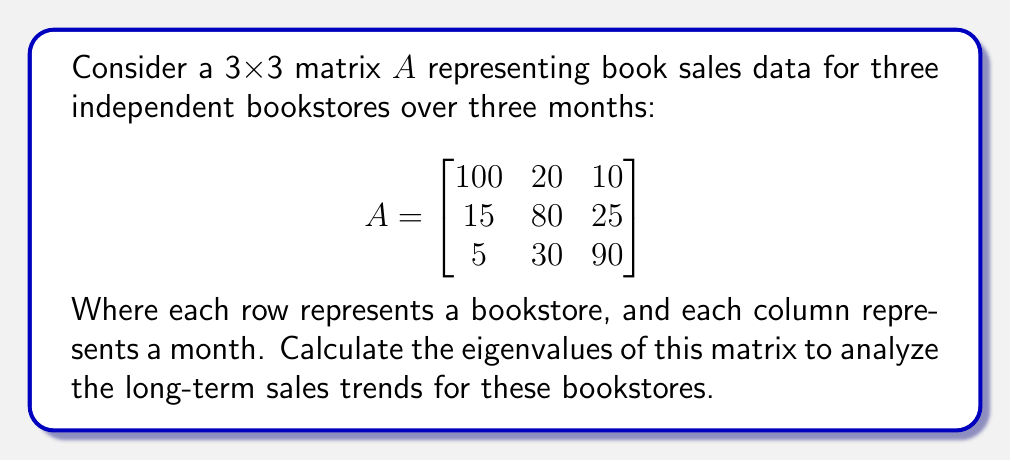Can you answer this question? To find the eigenvalues of matrix A, we need to solve the characteristic equation:

1) First, we calculate det(A - λI), where I is the 3x3 identity matrix:

   $$det\begin{pmatrix}
   100-λ & 20 & 10 \\
   15 & 80-λ & 25 \\
   5 & 30 & 90-λ
   \end{pmatrix} = 0$$

2) Expand the determinant:
   $$(100-λ)[(80-λ)(90-λ) - 750] - 20[15(90-λ) - 125] + 10[15(30) - 5(80-λ)]$$
   
3) Simplify:
   $$(100-λ)(7200-170λ+λ^2) - 20(1350-15λ) + 10(450-400+5λ)$$
   
4) Expand further:
   $$720000 - 17000λ + 100λ^2 - 7200λ + 170λ^2 - λ^3 - 27000 + 300λ + 500 + 50λ$$
   
5) Collect like terms:
   $$-λ^3 + 270λ^2 - 23850λ + 693500 = 0$$

6) This is a cubic equation. We can solve it using the cubic formula or numerical methods. The solutions are the eigenvalues.

Using numerical methods, we find the eigenvalues are approximately:

λ₁ ≈ 122.39
λ₂ ≈ 90.80
λ₃ ≈ 56.81

These eigenvalues represent the principal axes of the sales data, with the largest eigenvalue (122.39) indicating the dominant trend in book sales across the three stores over time.
Answer: λ₁ ≈ 122.39, λ₂ ≈ 90.80, λ₃ ≈ 56.81 